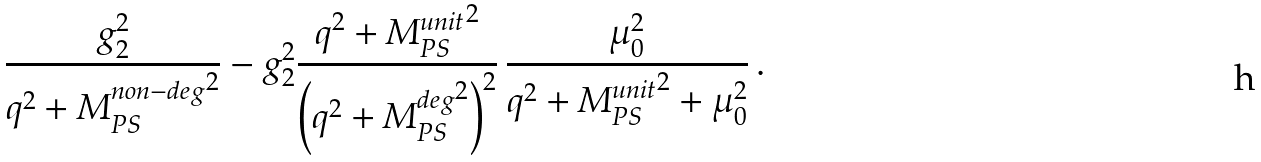Convert formula to latex. <formula><loc_0><loc_0><loc_500><loc_500>\frac { g _ { 2 } ^ { 2 } } { q ^ { 2 } + { M ^ { n o n - d e g } _ { P S } } ^ { 2 } } - g _ { 2 } ^ { 2 } \frac { q ^ { 2 } + { M ^ { u n i t } _ { P S } } ^ { 2 } } { \left ( q ^ { 2 } + { M ^ { d e g } _ { P S } } ^ { 2 } \right ) ^ { 2 } } \, \frac { \mu _ { 0 } ^ { 2 } } { q ^ { 2 } + { M ^ { u n i t } _ { P S } } ^ { 2 } + \mu _ { 0 } ^ { 2 } } \, .</formula> 